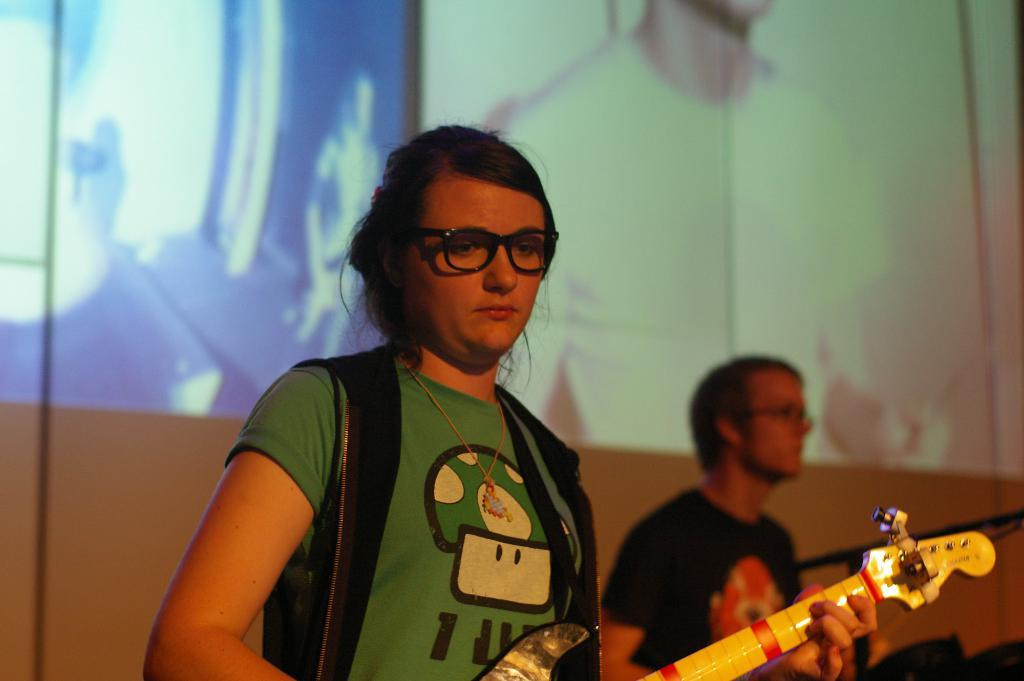How many people are in the image? There are two people in the image, a woman and a man. What is the woman wearing in the image? The woman is wearing glasses (specs) in the image. What is the woman holding in the image? The woman is holding a guitar in the image. What type of stitch is the woman using to sew the deer in the image? There is no deer or sewing activity present in the image. 